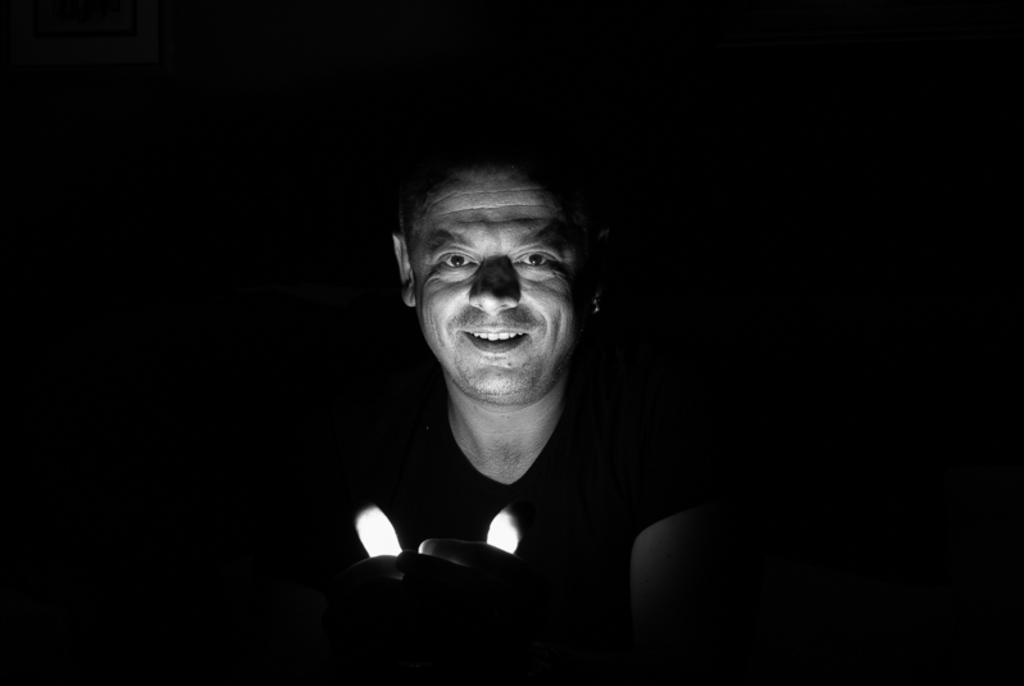Who or what is the main subject of the image? There is a person in the image. What can be observed about the environment in the image? The background of the image is dark. What type of mint is being used by the person in the image? There is no mint present in the image, and the person's actions or activities are not described. 